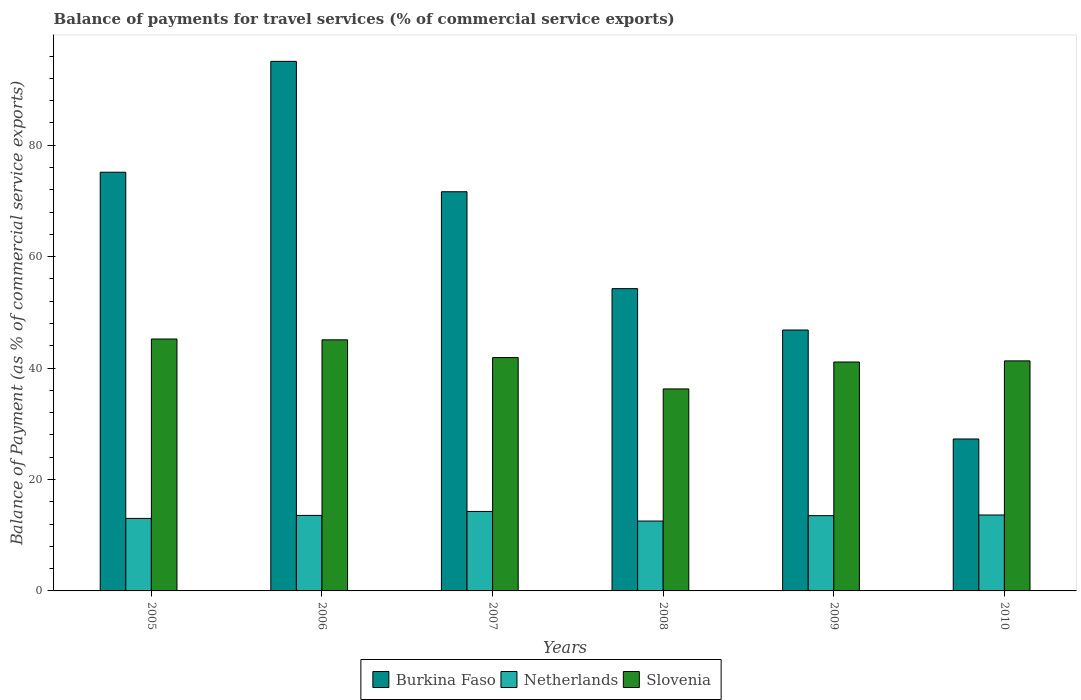How many different coloured bars are there?
Your response must be concise. 3. Are the number of bars per tick equal to the number of legend labels?
Provide a succinct answer. Yes. Are the number of bars on each tick of the X-axis equal?
Offer a terse response. Yes. How many bars are there on the 3rd tick from the left?
Provide a short and direct response. 3. How many bars are there on the 4th tick from the right?
Your answer should be compact. 3. What is the label of the 2nd group of bars from the left?
Your response must be concise. 2006. What is the balance of payments for travel services in Netherlands in 2009?
Your answer should be very brief. 13.51. Across all years, what is the maximum balance of payments for travel services in Burkina Faso?
Provide a succinct answer. 95.05. Across all years, what is the minimum balance of payments for travel services in Burkina Faso?
Give a very brief answer. 27.27. What is the total balance of payments for travel services in Netherlands in the graph?
Give a very brief answer. 80.51. What is the difference between the balance of payments for travel services in Slovenia in 2006 and that in 2007?
Offer a very short reply. 3.18. What is the difference between the balance of payments for travel services in Slovenia in 2005 and the balance of payments for travel services in Burkina Faso in 2009?
Provide a succinct answer. -1.61. What is the average balance of payments for travel services in Netherlands per year?
Offer a very short reply. 13.42. In the year 2005, what is the difference between the balance of payments for travel services in Burkina Faso and balance of payments for travel services in Netherlands?
Ensure brevity in your answer.  62.13. In how many years, is the balance of payments for travel services in Slovenia greater than 60 %?
Your answer should be compact. 0. What is the ratio of the balance of payments for travel services in Burkina Faso in 2009 to that in 2010?
Ensure brevity in your answer.  1.72. What is the difference between the highest and the second highest balance of payments for travel services in Slovenia?
Offer a very short reply. 0.15. What is the difference between the highest and the lowest balance of payments for travel services in Slovenia?
Give a very brief answer. 8.96. Is the sum of the balance of payments for travel services in Burkina Faso in 2005 and 2007 greater than the maximum balance of payments for travel services in Slovenia across all years?
Ensure brevity in your answer.  Yes. What does the 3rd bar from the left in 2007 represents?
Make the answer very short. Slovenia. What does the 3rd bar from the right in 2007 represents?
Make the answer very short. Burkina Faso. Is it the case that in every year, the sum of the balance of payments for travel services in Netherlands and balance of payments for travel services in Slovenia is greater than the balance of payments for travel services in Burkina Faso?
Your response must be concise. No. How many years are there in the graph?
Provide a succinct answer. 6. What is the difference between two consecutive major ticks on the Y-axis?
Offer a terse response. 20. Are the values on the major ticks of Y-axis written in scientific E-notation?
Make the answer very short. No. Does the graph contain grids?
Offer a very short reply. No. Where does the legend appear in the graph?
Your response must be concise. Bottom center. How are the legend labels stacked?
Make the answer very short. Horizontal. What is the title of the graph?
Your answer should be compact. Balance of payments for travel services (% of commercial service exports). What is the label or title of the X-axis?
Your answer should be very brief. Years. What is the label or title of the Y-axis?
Offer a very short reply. Balance of Payment (as % of commercial service exports). What is the Balance of Payment (as % of commercial service exports) of Burkina Faso in 2005?
Offer a very short reply. 75.15. What is the Balance of Payment (as % of commercial service exports) of Netherlands in 2005?
Keep it short and to the point. 13.01. What is the Balance of Payment (as % of commercial service exports) of Slovenia in 2005?
Provide a succinct answer. 45.21. What is the Balance of Payment (as % of commercial service exports) in Burkina Faso in 2006?
Give a very brief answer. 95.05. What is the Balance of Payment (as % of commercial service exports) in Netherlands in 2006?
Provide a short and direct response. 13.55. What is the Balance of Payment (as % of commercial service exports) in Slovenia in 2006?
Give a very brief answer. 45.06. What is the Balance of Payment (as % of commercial service exports) in Burkina Faso in 2007?
Provide a succinct answer. 71.64. What is the Balance of Payment (as % of commercial service exports) of Netherlands in 2007?
Your answer should be compact. 14.27. What is the Balance of Payment (as % of commercial service exports) in Slovenia in 2007?
Your response must be concise. 41.88. What is the Balance of Payment (as % of commercial service exports) in Burkina Faso in 2008?
Your response must be concise. 54.25. What is the Balance of Payment (as % of commercial service exports) in Netherlands in 2008?
Offer a very short reply. 12.54. What is the Balance of Payment (as % of commercial service exports) in Slovenia in 2008?
Ensure brevity in your answer.  36.25. What is the Balance of Payment (as % of commercial service exports) in Burkina Faso in 2009?
Your answer should be compact. 46.83. What is the Balance of Payment (as % of commercial service exports) in Netherlands in 2009?
Provide a short and direct response. 13.51. What is the Balance of Payment (as % of commercial service exports) of Slovenia in 2009?
Offer a terse response. 41.09. What is the Balance of Payment (as % of commercial service exports) of Burkina Faso in 2010?
Give a very brief answer. 27.27. What is the Balance of Payment (as % of commercial service exports) in Netherlands in 2010?
Your response must be concise. 13.63. What is the Balance of Payment (as % of commercial service exports) of Slovenia in 2010?
Ensure brevity in your answer.  41.29. Across all years, what is the maximum Balance of Payment (as % of commercial service exports) of Burkina Faso?
Give a very brief answer. 95.05. Across all years, what is the maximum Balance of Payment (as % of commercial service exports) of Netherlands?
Your answer should be compact. 14.27. Across all years, what is the maximum Balance of Payment (as % of commercial service exports) of Slovenia?
Give a very brief answer. 45.21. Across all years, what is the minimum Balance of Payment (as % of commercial service exports) in Burkina Faso?
Provide a succinct answer. 27.27. Across all years, what is the minimum Balance of Payment (as % of commercial service exports) of Netherlands?
Offer a terse response. 12.54. Across all years, what is the minimum Balance of Payment (as % of commercial service exports) of Slovenia?
Provide a succinct answer. 36.25. What is the total Balance of Payment (as % of commercial service exports) of Burkina Faso in the graph?
Make the answer very short. 370.19. What is the total Balance of Payment (as % of commercial service exports) in Netherlands in the graph?
Your answer should be very brief. 80.51. What is the total Balance of Payment (as % of commercial service exports) of Slovenia in the graph?
Ensure brevity in your answer.  250.78. What is the difference between the Balance of Payment (as % of commercial service exports) of Burkina Faso in 2005 and that in 2006?
Your answer should be very brief. -19.9. What is the difference between the Balance of Payment (as % of commercial service exports) of Netherlands in 2005 and that in 2006?
Give a very brief answer. -0.54. What is the difference between the Balance of Payment (as % of commercial service exports) in Slovenia in 2005 and that in 2006?
Ensure brevity in your answer.  0.15. What is the difference between the Balance of Payment (as % of commercial service exports) of Burkina Faso in 2005 and that in 2007?
Keep it short and to the point. 3.5. What is the difference between the Balance of Payment (as % of commercial service exports) of Netherlands in 2005 and that in 2007?
Give a very brief answer. -1.25. What is the difference between the Balance of Payment (as % of commercial service exports) in Slovenia in 2005 and that in 2007?
Keep it short and to the point. 3.33. What is the difference between the Balance of Payment (as % of commercial service exports) of Burkina Faso in 2005 and that in 2008?
Give a very brief answer. 20.9. What is the difference between the Balance of Payment (as % of commercial service exports) in Netherlands in 2005 and that in 2008?
Keep it short and to the point. 0.47. What is the difference between the Balance of Payment (as % of commercial service exports) of Slovenia in 2005 and that in 2008?
Your response must be concise. 8.96. What is the difference between the Balance of Payment (as % of commercial service exports) of Burkina Faso in 2005 and that in 2009?
Offer a very short reply. 28.32. What is the difference between the Balance of Payment (as % of commercial service exports) in Netherlands in 2005 and that in 2009?
Your response must be concise. -0.49. What is the difference between the Balance of Payment (as % of commercial service exports) of Slovenia in 2005 and that in 2009?
Your response must be concise. 4.13. What is the difference between the Balance of Payment (as % of commercial service exports) in Burkina Faso in 2005 and that in 2010?
Your response must be concise. 47.88. What is the difference between the Balance of Payment (as % of commercial service exports) in Netherlands in 2005 and that in 2010?
Your answer should be compact. -0.61. What is the difference between the Balance of Payment (as % of commercial service exports) in Slovenia in 2005 and that in 2010?
Your response must be concise. 3.93. What is the difference between the Balance of Payment (as % of commercial service exports) of Burkina Faso in 2006 and that in 2007?
Provide a succinct answer. 23.4. What is the difference between the Balance of Payment (as % of commercial service exports) of Netherlands in 2006 and that in 2007?
Provide a succinct answer. -0.71. What is the difference between the Balance of Payment (as % of commercial service exports) of Slovenia in 2006 and that in 2007?
Offer a terse response. 3.18. What is the difference between the Balance of Payment (as % of commercial service exports) in Burkina Faso in 2006 and that in 2008?
Offer a terse response. 40.8. What is the difference between the Balance of Payment (as % of commercial service exports) of Netherlands in 2006 and that in 2008?
Offer a terse response. 1.01. What is the difference between the Balance of Payment (as % of commercial service exports) in Slovenia in 2006 and that in 2008?
Your answer should be compact. 8.81. What is the difference between the Balance of Payment (as % of commercial service exports) in Burkina Faso in 2006 and that in 2009?
Your answer should be compact. 48.22. What is the difference between the Balance of Payment (as % of commercial service exports) in Netherlands in 2006 and that in 2009?
Keep it short and to the point. 0.05. What is the difference between the Balance of Payment (as % of commercial service exports) of Slovenia in 2006 and that in 2009?
Ensure brevity in your answer.  3.98. What is the difference between the Balance of Payment (as % of commercial service exports) in Burkina Faso in 2006 and that in 2010?
Keep it short and to the point. 67.78. What is the difference between the Balance of Payment (as % of commercial service exports) in Netherlands in 2006 and that in 2010?
Keep it short and to the point. -0.07. What is the difference between the Balance of Payment (as % of commercial service exports) of Slovenia in 2006 and that in 2010?
Make the answer very short. 3.78. What is the difference between the Balance of Payment (as % of commercial service exports) in Burkina Faso in 2007 and that in 2008?
Keep it short and to the point. 17.39. What is the difference between the Balance of Payment (as % of commercial service exports) in Netherlands in 2007 and that in 2008?
Provide a succinct answer. 1.73. What is the difference between the Balance of Payment (as % of commercial service exports) of Slovenia in 2007 and that in 2008?
Your answer should be compact. 5.63. What is the difference between the Balance of Payment (as % of commercial service exports) in Burkina Faso in 2007 and that in 2009?
Keep it short and to the point. 24.82. What is the difference between the Balance of Payment (as % of commercial service exports) in Netherlands in 2007 and that in 2009?
Provide a short and direct response. 0.76. What is the difference between the Balance of Payment (as % of commercial service exports) of Slovenia in 2007 and that in 2009?
Provide a short and direct response. 0.79. What is the difference between the Balance of Payment (as % of commercial service exports) of Burkina Faso in 2007 and that in 2010?
Offer a terse response. 44.37. What is the difference between the Balance of Payment (as % of commercial service exports) of Netherlands in 2007 and that in 2010?
Offer a very short reply. 0.64. What is the difference between the Balance of Payment (as % of commercial service exports) of Slovenia in 2007 and that in 2010?
Your answer should be very brief. 0.59. What is the difference between the Balance of Payment (as % of commercial service exports) of Burkina Faso in 2008 and that in 2009?
Your answer should be compact. 7.42. What is the difference between the Balance of Payment (as % of commercial service exports) of Netherlands in 2008 and that in 2009?
Provide a succinct answer. -0.96. What is the difference between the Balance of Payment (as % of commercial service exports) of Slovenia in 2008 and that in 2009?
Your answer should be compact. -4.83. What is the difference between the Balance of Payment (as % of commercial service exports) of Burkina Faso in 2008 and that in 2010?
Offer a terse response. 26.98. What is the difference between the Balance of Payment (as % of commercial service exports) of Netherlands in 2008 and that in 2010?
Provide a short and direct response. -1.09. What is the difference between the Balance of Payment (as % of commercial service exports) in Slovenia in 2008 and that in 2010?
Provide a succinct answer. -5.03. What is the difference between the Balance of Payment (as % of commercial service exports) in Burkina Faso in 2009 and that in 2010?
Give a very brief answer. 19.56. What is the difference between the Balance of Payment (as % of commercial service exports) in Netherlands in 2009 and that in 2010?
Provide a short and direct response. -0.12. What is the difference between the Balance of Payment (as % of commercial service exports) of Slovenia in 2009 and that in 2010?
Your answer should be very brief. -0.2. What is the difference between the Balance of Payment (as % of commercial service exports) in Burkina Faso in 2005 and the Balance of Payment (as % of commercial service exports) in Netherlands in 2006?
Offer a terse response. 61.59. What is the difference between the Balance of Payment (as % of commercial service exports) in Burkina Faso in 2005 and the Balance of Payment (as % of commercial service exports) in Slovenia in 2006?
Offer a very short reply. 30.08. What is the difference between the Balance of Payment (as % of commercial service exports) of Netherlands in 2005 and the Balance of Payment (as % of commercial service exports) of Slovenia in 2006?
Provide a short and direct response. -32.05. What is the difference between the Balance of Payment (as % of commercial service exports) in Burkina Faso in 2005 and the Balance of Payment (as % of commercial service exports) in Netherlands in 2007?
Your answer should be compact. 60.88. What is the difference between the Balance of Payment (as % of commercial service exports) of Burkina Faso in 2005 and the Balance of Payment (as % of commercial service exports) of Slovenia in 2007?
Make the answer very short. 33.27. What is the difference between the Balance of Payment (as % of commercial service exports) in Netherlands in 2005 and the Balance of Payment (as % of commercial service exports) in Slovenia in 2007?
Offer a terse response. -28.87. What is the difference between the Balance of Payment (as % of commercial service exports) of Burkina Faso in 2005 and the Balance of Payment (as % of commercial service exports) of Netherlands in 2008?
Your response must be concise. 62.61. What is the difference between the Balance of Payment (as % of commercial service exports) of Burkina Faso in 2005 and the Balance of Payment (as % of commercial service exports) of Slovenia in 2008?
Ensure brevity in your answer.  38.89. What is the difference between the Balance of Payment (as % of commercial service exports) in Netherlands in 2005 and the Balance of Payment (as % of commercial service exports) in Slovenia in 2008?
Your answer should be compact. -23.24. What is the difference between the Balance of Payment (as % of commercial service exports) in Burkina Faso in 2005 and the Balance of Payment (as % of commercial service exports) in Netherlands in 2009?
Provide a short and direct response. 61.64. What is the difference between the Balance of Payment (as % of commercial service exports) of Burkina Faso in 2005 and the Balance of Payment (as % of commercial service exports) of Slovenia in 2009?
Ensure brevity in your answer.  34.06. What is the difference between the Balance of Payment (as % of commercial service exports) of Netherlands in 2005 and the Balance of Payment (as % of commercial service exports) of Slovenia in 2009?
Offer a very short reply. -28.07. What is the difference between the Balance of Payment (as % of commercial service exports) in Burkina Faso in 2005 and the Balance of Payment (as % of commercial service exports) in Netherlands in 2010?
Keep it short and to the point. 61.52. What is the difference between the Balance of Payment (as % of commercial service exports) of Burkina Faso in 2005 and the Balance of Payment (as % of commercial service exports) of Slovenia in 2010?
Ensure brevity in your answer.  33.86. What is the difference between the Balance of Payment (as % of commercial service exports) in Netherlands in 2005 and the Balance of Payment (as % of commercial service exports) in Slovenia in 2010?
Keep it short and to the point. -28.27. What is the difference between the Balance of Payment (as % of commercial service exports) of Burkina Faso in 2006 and the Balance of Payment (as % of commercial service exports) of Netherlands in 2007?
Provide a short and direct response. 80.78. What is the difference between the Balance of Payment (as % of commercial service exports) in Burkina Faso in 2006 and the Balance of Payment (as % of commercial service exports) in Slovenia in 2007?
Your response must be concise. 53.16. What is the difference between the Balance of Payment (as % of commercial service exports) of Netherlands in 2006 and the Balance of Payment (as % of commercial service exports) of Slovenia in 2007?
Your answer should be very brief. -28.33. What is the difference between the Balance of Payment (as % of commercial service exports) of Burkina Faso in 2006 and the Balance of Payment (as % of commercial service exports) of Netherlands in 2008?
Give a very brief answer. 82.5. What is the difference between the Balance of Payment (as % of commercial service exports) in Burkina Faso in 2006 and the Balance of Payment (as % of commercial service exports) in Slovenia in 2008?
Make the answer very short. 58.79. What is the difference between the Balance of Payment (as % of commercial service exports) of Netherlands in 2006 and the Balance of Payment (as % of commercial service exports) of Slovenia in 2008?
Keep it short and to the point. -22.7. What is the difference between the Balance of Payment (as % of commercial service exports) of Burkina Faso in 2006 and the Balance of Payment (as % of commercial service exports) of Netherlands in 2009?
Provide a short and direct response. 81.54. What is the difference between the Balance of Payment (as % of commercial service exports) in Burkina Faso in 2006 and the Balance of Payment (as % of commercial service exports) in Slovenia in 2009?
Provide a short and direct response. 53.96. What is the difference between the Balance of Payment (as % of commercial service exports) in Netherlands in 2006 and the Balance of Payment (as % of commercial service exports) in Slovenia in 2009?
Make the answer very short. -27.53. What is the difference between the Balance of Payment (as % of commercial service exports) of Burkina Faso in 2006 and the Balance of Payment (as % of commercial service exports) of Netherlands in 2010?
Give a very brief answer. 81.42. What is the difference between the Balance of Payment (as % of commercial service exports) in Burkina Faso in 2006 and the Balance of Payment (as % of commercial service exports) in Slovenia in 2010?
Your answer should be compact. 53.76. What is the difference between the Balance of Payment (as % of commercial service exports) in Netherlands in 2006 and the Balance of Payment (as % of commercial service exports) in Slovenia in 2010?
Ensure brevity in your answer.  -27.73. What is the difference between the Balance of Payment (as % of commercial service exports) of Burkina Faso in 2007 and the Balance of Payment (as % of commercial service exports) of Netherlands in 2008?
Keep it short and to the point. 59.1. What is the difference between the Balance of Payment (as % of commercial service exports) of Burkina Faso in 2007 and the Balance of Payment (as % of commercial service exports) of Slovenia in 2008?
Your answer should be very brief. 35.39. What is the difference between the Balance of Payment (as % of commercial service exports) in Netherlands in 2007 and the Balance of Payment (as % of commercial service exports) in Slovenia in 2008?
Give a very brief answer. -21.99. What is the difference between the Balance of Payment (as % of commercial service exports) in Burkina Faso in 2007 and the Balance of Payment (as % of commercial service exports) in Netherlands in 2009?
Make the answer very short. 58.14. What is the difference between the Balance of Payment (as % of commercial service exports) of Burkina Faso in 2007 and the Balance of Payment (as % of commercial service exports) of Slovenia in 2009?
Provide a short and direct response. 30.56. What is the difference between the Balance of Payment (as % of commercial service exports) in Netherlands in 2007 and the Balance of Payment (as % of commercial service exports) in Slovenia in 2009?
Ensure brevity in your answer.  -26.82. What is the difference between the Balance of Payment (as % of commercial service exports) in Burkina Faso in 2007 and the Balance of Payment (as % of commercial service exports) in Netherlands in 2010?
Your response must be concise. 58.02. What is the difference between the Balance of Payment (as % of commercial service exports) in Burkina Faso in 2007 and the Balance of Payment (as % of commercial service exports) in Slovenia in 2010?
Give a very brief answer. 30.36. What is the difference between the Balance of Payment (as % of commercial service exports) in Netherlands in 2007 and the Balance of Payment (as % of commercial service exports) in Slovenia in 2010?
Offer a terse response. -27.02. What is the difference between the Balance of Payment (as % of commercial service exports) of Burkina Faso in 2008 and the Balance of Payment (as % of commercial service exports) of Netherlands in 2009?
Your answer should be compact. 40.74. What is the difference between the Balance of Payment (as % of commercial service exports) of Burkina Faso in 2008 and the Balance of Payment (as % of commercial service exports) of Slovenia in 2009?
Give a very brief answer. 13.16. What is the difference between the Balance of Payment (as % of commercial service exports) of Netherlands in 2008 and the Balance of Payment (as % of commercial service exports) of Slovenia in 2009?
Keep it short and to the point. -28.54. What is the difference between the Balance of Payment (as % of commercial service exports) in Burkina Faso in 2008 and the Balance of Payment (as % of commercial service exports) in Netherlands in 2010?
Ensure brevity in your answer.  40.62. What is the difference between the Balance of Payment (as % of commercial service exports) in Burkina Faso in 2008 and the Balance of Payment (as % of commercial service exports) in Slovenia in 2010?
Provide a succinct answer. 12.96. What is the difference between the Balance of Payment (as % of commercial service exports) of Netherlands in 2008 and the Balance of Payment (as % of commercial service exports) of Slovenia in 2010?
Provide a short and direct response. -28.74. What is the difference between the Balance of Payment (as % of commercial service exports) of Burkina Faso in 2009 and the Balance of Payment (as % of commercial service exports) of Netherlands in 2010?
Provide a succinct answer. 33.2. What is the difference between the Balance of Payment (as % of commercial service exports) of Burkina Faso in 2009 and the Balance of Payment (as % of commercial service exports) of Slovenia in 2010?
Give a very brief answer. 5.54. What is the difference between the Balance of Payment (as % of commercial service exports) of Netherlands in 2009 and the Balance of Payment (as % of commercial service exports) of Slovenia in 2010?
Offer a very short reply. -27.78. What is the average Balance of Payment (as % of commercial service exports) of Burkina Faso per year?
Make the answer very short. 61.7. What is the average Balance of Payment (as % of commercial service exports) in Netherlands per year?
Provide a succinct answer. 13.42. What is the average Balance of Payment (as % of commercial service exports) in Slovenia per year?
Give a very brief answer. 41.8. In the year 2005, what is the difference between the Balance of Payment (as % of commercial service exports) of Burkina Faso and Balance of Payment (as % of commercial service exports) of Netherlands?
Offer a very short reply. 62.13. In the year 2005, what is the difference between the Balance of Payment (as % of commercial service exports) of Burkina Faso and Balance of Payment (as % of commercial service exports) of Slovenia?
Provide a short and direct response. 29.94. In the year 2005, what is the difference between the Balance of Payment (as % of commercial service exports) of Netherlands and Balance of Payment (as % of commercial service exports) of Slovenia?
Keep it short and to the point. -32.2. In the year 2006, what is the difference between the Balance of Payment (as % of commercial service exports) in Burkina Faso and Balance of Payment (as % of commercial service exports) in Netherlands?
Keep it short and to the point. 81.49. In the year 2006, what is the difference between the Balance of Payment (as % of commercial service exports) in Burkina Faso and Balance of Payment (as % of commercial service exports) in Slovenia?
Give a very brief answer. 49.98. In the year 2006, what is the difference between the Balance of Payment (as % of commercial service exports) of Netherlands and Balance of Payment (as % of commercial service exports) of Slovenia?
Give a very brief answer. -31.51. In the year 2007, what is the difference between the Balance of Payment (as % of commercial service exports) in Burkina Faso and Balance of Payment (as % of commercial service exports) in Netherlands?
Ensure brevity in your answer.  57.38. In the year 2007, what is the difference between the Balance of Payment (as % of commercial service exports) of Burkina Faso and Balance of Payment (as % of commercial service exports) of Slovenia?
Ensure brevity in your answer.  29.76. In the year 2007, what is the difference between the Balance of Payment (as % of commercial service exports) in Netherlands and Balance of Payment (as % of commercial service exports) in Slovenia?
Your answer should be very brief. -27.61. In the year 2008, what is the difference between the Balance of Payment (as % of commercial service exports) in Burkina Faso and Balance of Payment (as % of commercial service exports) in Netherlands?
Ensure brevity in your answer.  41.71. In the year 2008, what is the difference between the Balance of Payment (as % of commercial service exports) in Burkina Faso and Balance of Payment (as % of commercial service exports) in Slovenia?
Keep it short and to the point. 18. In the year 2008, what is the difference between the Balance of Payment (as % of commercial service exports) in Netherlands and Balance of Payment (as % of commercial service exports) in Slovenia?
Make the answer very short. -23.71. In the year 2009, what is the difference between the Balance of Payment (as % of commercial service exports) of Burkina Faso and Balance of Payment (as % of commercial service exports) of Netherlands?
Keep it short and to the point. 33.32. In the year 2009, what is the difference between the Balance of Payment (as % of commercial service exports) of Burkina Faso and Balance of Payment (as % of commercial service exports) of Slovenia?
Ensure brevity in your answer.  5.74. In the year 2009, what is the difference between the Balance of Payment (as % of commercial service exports) in Netherlands and Balance of Payment (as % of commercial service exports) in Slovenia?
Offer a terse response. -27.58. In the year 2010, what is the difference between the Balance of Payment (as % of commercial service exports) in Burkina Faso and Balance of Payment (as % of commercial service exports) in Netherlands?
Give a very brief answer. 13.64. In the year 2010, what is the difference between the Balance of Payment (as % of commercial service exports) in Burkina Faso and Balance of Payment (as % of commercial service exports) in Slovenia?
Provide a short and direct response. -14.02. In the year 2010, what is the difference between the Balance of Payment (as % of commercial service exports) in Netherlands and Balance of Payment (as % of commercial service exports) in Slovenia?
Make the answer very short. -27.66. What is the ratio of the Balance of Payment (as % of commercial service exports) in Burkina Faso in 2005 to that in 2006?
Give a very brief answer. 0.79. What is the ratio of the Balance of Payment (as % of commercial service exports) in Netherlands in 2005 to that in 2006?
Your answer should be very brief. 0.96. What is the ratio of the Balance of Payment (as % of commercial service exports) in Burkina Faso in 2005 to that in 2007?
Offer a very short reply. 1.05. What is the ratio of the Balance of Payment (as % of commercial service exports) in Netherlands in 2005 to that in 2007?
Your response must be concise. 0.91. What is the ratio of the Balance of Payment (as % of commercial service exports) in Slovenia in 2005 to that in 2007?
Give a very brief answer. 1.08. What is the ratio of the Balance of Payment (as % of commercial service exports) in Burkina Faso in 2005 to that in 2008?
Offer a terse response. 1.39. What is the ratio of the Balance of Payment (as % of commercial service exports) of Netherlands in 2005 to that in 2008?
Provide a short and direct response. 1.04. What is the ratio of the Balance of Payment (as % of commercial service exports) in Slovenia in 2005 to that in 2008?
Provide a short and direct response. 1.25. What is the ratio of the Balance of Payment (as % of commercial service exports) in Burkina Faso in 2005 to that in 2009?
Your response must be concise. 1.6. What is the ratio of the Balance of Payment (as % of commercial service exports) of Netherlands in 2005 to that in 2009?
Provide a succinct answer. 0.96. What is the ratio of the Balance of Payment (as % of commercial service exports) in Slovenia in 2005 to that in 2009?
Make the answer very short. 1.1. What is the ratio of the Balance of Payment (as % of commercial service exports) in Burkina Faso in 2005 to that in 2010?
Keep it short and to the point. 2.76. What is the ratio of the Balance of Payment (as % of commercial service exports) of Netherlands in 2005 to that in 2010?
Give a very brief answer. 0.95. What is the ratio of the Balance of Payment (as % of commercial service exports) in Slovenia in 2005 to that in 2010?
Provide a short and direct response. 1.1. What is the ratio of the Balance of Payment (as % of commercial service exports) of Burkina Faso in 2006 to that in 2007?
Give a very brief answer. 1.33. What is the ratio of the Balance of Payment (as % of commercial service exports) of Netherlands in 2006 to that in 2007?
Provide a succinct answer. 0.95. What is the ratio of the Balance of Payment (as % of commercial service exports) in Slovenia in 2006 to that in 2007?
Your answer should be very brief. 1.08. What is the ratio of the Balance of Payment (as % of commercial service exports) of Burkina Faso in 2006 to that in 2008?
Your response must be concise. 1.75. What is the ratio of the Balance of Payment (as % of commercial service exports) in Netherlands in 2006 to that in 2008?
Give a very brief answer. 1.08. What is the ratio of the Balance of Payment (as % of commercial service exports) in Slovenia in 2006 to that in 2008?
Your response must be concise. 1.24. What is the ratio of the Balance of Payment (as % of commercial service exports) of Burkina Faso in 2006 to that in 2009?
Provide a succinct answer. 2.03. What is the ratio of the Balance of Payment (as % of commercial service exports) of Slovenia in 2006 to that in 2009?
Offer a terse response. 1.1. What is the ratio of the Balance of Payment (as % of commercial service exports) in Burkina Faso in 2006 to that in 2010?
Provide a short and direct response. 3.49. What is the ratio of the Balance of Payment (as % of commercial service exports) in Netherlands in 2006 to that in 2010?
Your answer should be compact. 0.99. What is the ratio of the Balance of Payment (as % of commercial service exports) in Slovenia in 2006 to that in 2010?
Provide a short and direct response. 1.09. What is the ratio of the Balance of Payment (as % of commercial service exports) of Burkina Faso in 2007 to that in 2008?
Ensure brevity in your answer.  1.32. What is the ratio of the Balance of Payment (as % of commercial service exports) in Netherlands in 2007 to that in 2008?
Make the answer very short. 1.14. What is the ratio of the Balance of Payment (as % of commercial service exports) of Slovenia in 2007 to that in 2008?
Give a very brief answer. 1.16. What is the ratio of the Balance of Payment (as % of commercial service exports) in Burkina Faso in 2007 to that in 2009?
Provide a succinct answer. 1.53. What is the ratio of the Balance of Payment (as % of commercial service exports) in Netherlands in 2007 to that in 2009?
Offer a very short reply. 1.06. What is the ratio of the Balance of Payment (as % of commercial service exports) in Slovenia in 2007 to that in 2009?
Give a very brief answer. 1.02. What is the ratio of the Balance of Payment (as % of commercial service exports) in Burkina Faso in 2007 to that in 2010?
Provide a short and direct response. 2.63. What is the ratio of the Balance of Payment (as % of commercial service exports) of Netherlands in 2007 to that in 2010?
Your answer should be very brief. 1.05. What is the ratio of the Balance of Payment (as % of commercial service exports) in Slovenia in 2007 to that in 2010?
Ensure brevity in your answer.  1.01. What is the ratio of the Balance of Payment (as % of commercial service exports) in Burkina Faso in 2008 to that in 2009?
Offer a very short reply. 1.16. What is the ratio of the Balance of Payment (as % of commercial service exports) of Slovenia in 2008 to that in 2009?
Provide a short and direct response. 0.88. What is the ratio of the Balance of Payment (as % of commercial service exports) in Burkina Faso in 2008 to that in 2010?
Keep it short and to the point. 1.99. What is the ratio of the Balance of Payment (as % of commercial service exports) of Netherlands in 2008 to that in 2010?
Keep it short and to the point. 0.92. What is the ratio of the Balance of Payment (as % of commercial service exports) of Slovenia in 2008 to that in 2010?
Your answer should be compact. 0.88. What is the ratio of the Balance of Payment (as % of commercial service exports) of Burkina Faso in 2009 to that in 2010?
Give a very brief answer. 1.72. What is the ratio of the Balance of Payment (as % of commercial service exports) of Netherlands in 2009 to that in 2010?
Offer a terse response. 0.99. What is the difference between the highest and the second highest Balance of Payment (as % of commercial service exports) of Burkina Faso?
Your answer should be compact. 19.9. What is the difference between the highest and the second highest Balance of Payment (as % of commercial service exports) of Netherlands?
Provide a succinct answer. 0.64. What is the difference between the highest and the second highest Balance of Payment (as % of commercial service exports) in Slovenia?
Your answer should be compact. 0.15. What is the difference between the highest and the lowest Balance of Payment (as % of commercial service exports) of Burkina Faso?
Ensure brevity in your answer.  67.78. What is the difference between the highest and the lowest Balance of Payment (as % of commercial service exports) in Netherlands?
Offer a terse response. 1.73. What is the difference between the highest and the lowest Balance of Payment (as % of commercial service exports) in Slovenia?
Your answer should be very brief. 8.96. 